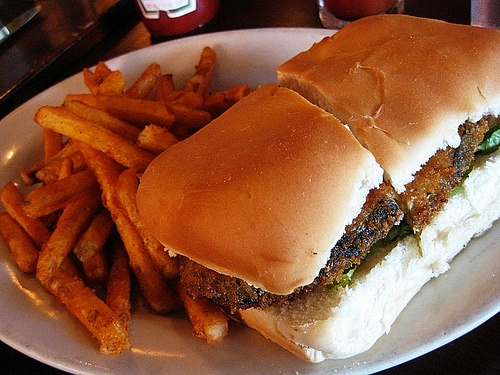Describe the objects in this image and their specific colors. I can see dining table in brown, maroon, black, and white tones, sandwich in black, brown, white, and tan tones, bottle in black, maroon, and lavender tones, cup in black, maroon, and brown tones, and knife in black, maroon, and gray tones in this image. 